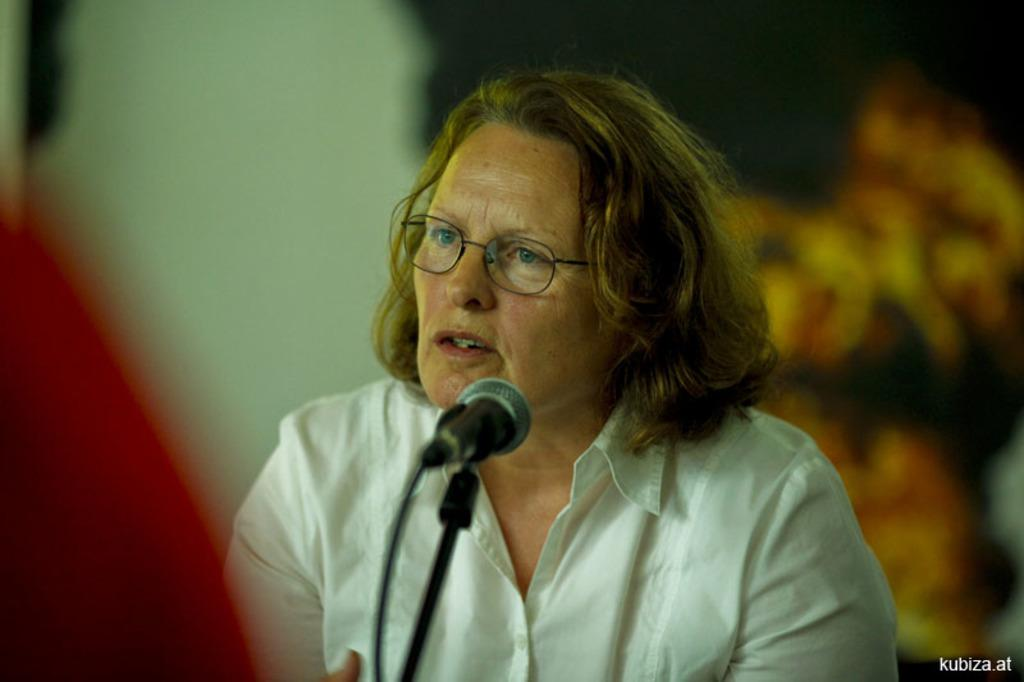Who is the main subject in the image? There is a woman in the image. What object is in front of the woman? There is a microphone in front of the woman. Can you describe the background of the image? The background of the image is blurry. Is there any text visible in the image? Yes, there is some text at the right bottom of the image. How many toy spiders are crawling on the woman's shoulder in the image? There are no toy spiders present in the image. What advice does the woman's father give her in the image? There is no reference to the woman's father or any advice in the image. 